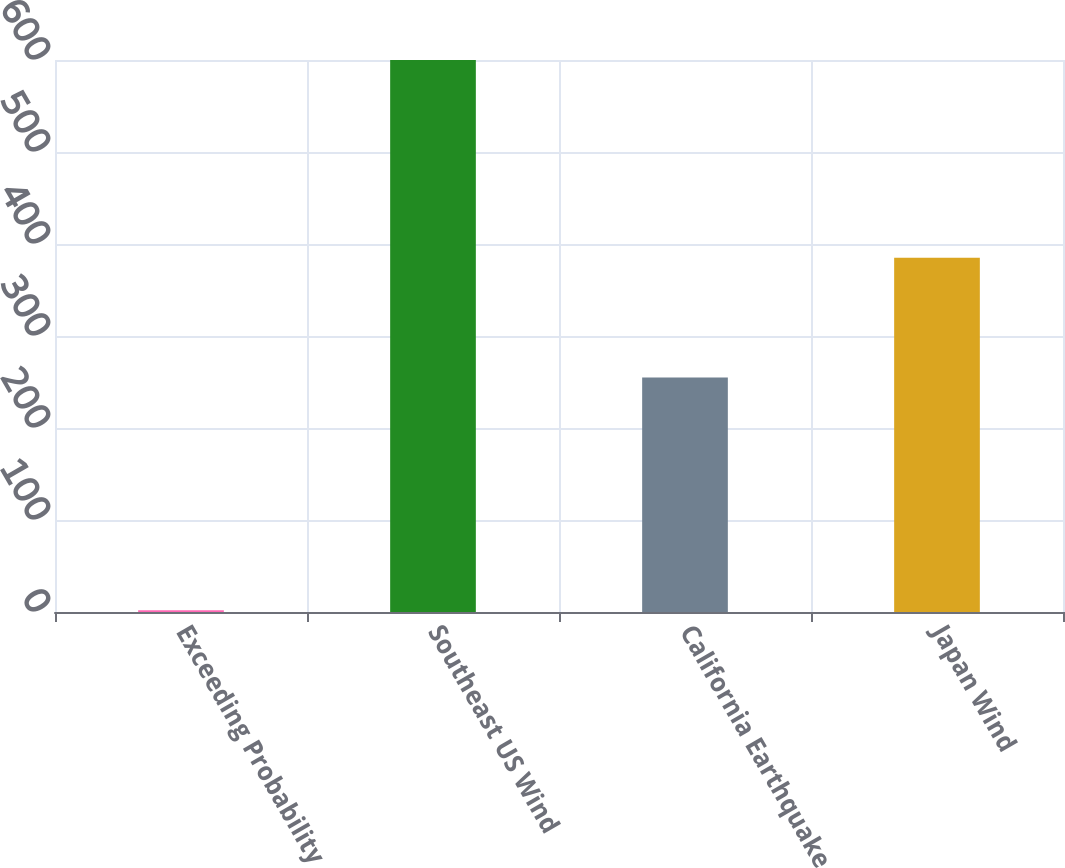Convert chart. <chart><loc_0><loc_0><loc_500><loc_500><bar_chart><fcel>Exceeding Probability<fcel>Southeast US Wind<fcel>California Earthquake<fcel>Japan Wind<nl><fcel>2<fcel>600<fcel>255<fcel>385<nl></chart> 